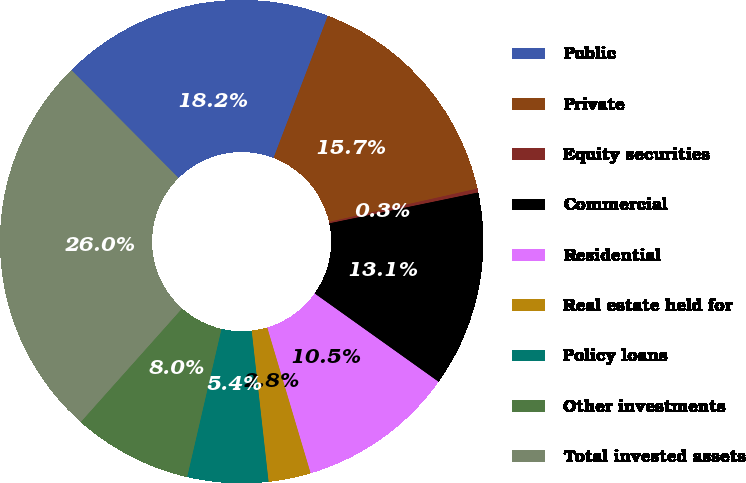<chart> <loc_0><loc_0><loc_500><loc_500><pie_chart><fcel>Public<fcel>Private<fcel>Equity securities<fcel>Commercial<fcel>Residential<fcel>Real estate held for<fcel>Policy loans<fcel>Other investments<fcel>Total invested assets<nl><fcel>18.25%<fcel>15.68%<fcel>0.26%<fcel>13.11%<fcel>10.54%<fcel>2.83%<fcel>5.4%<fcel>7.97%<fcel>25.96%<nl></chart> 